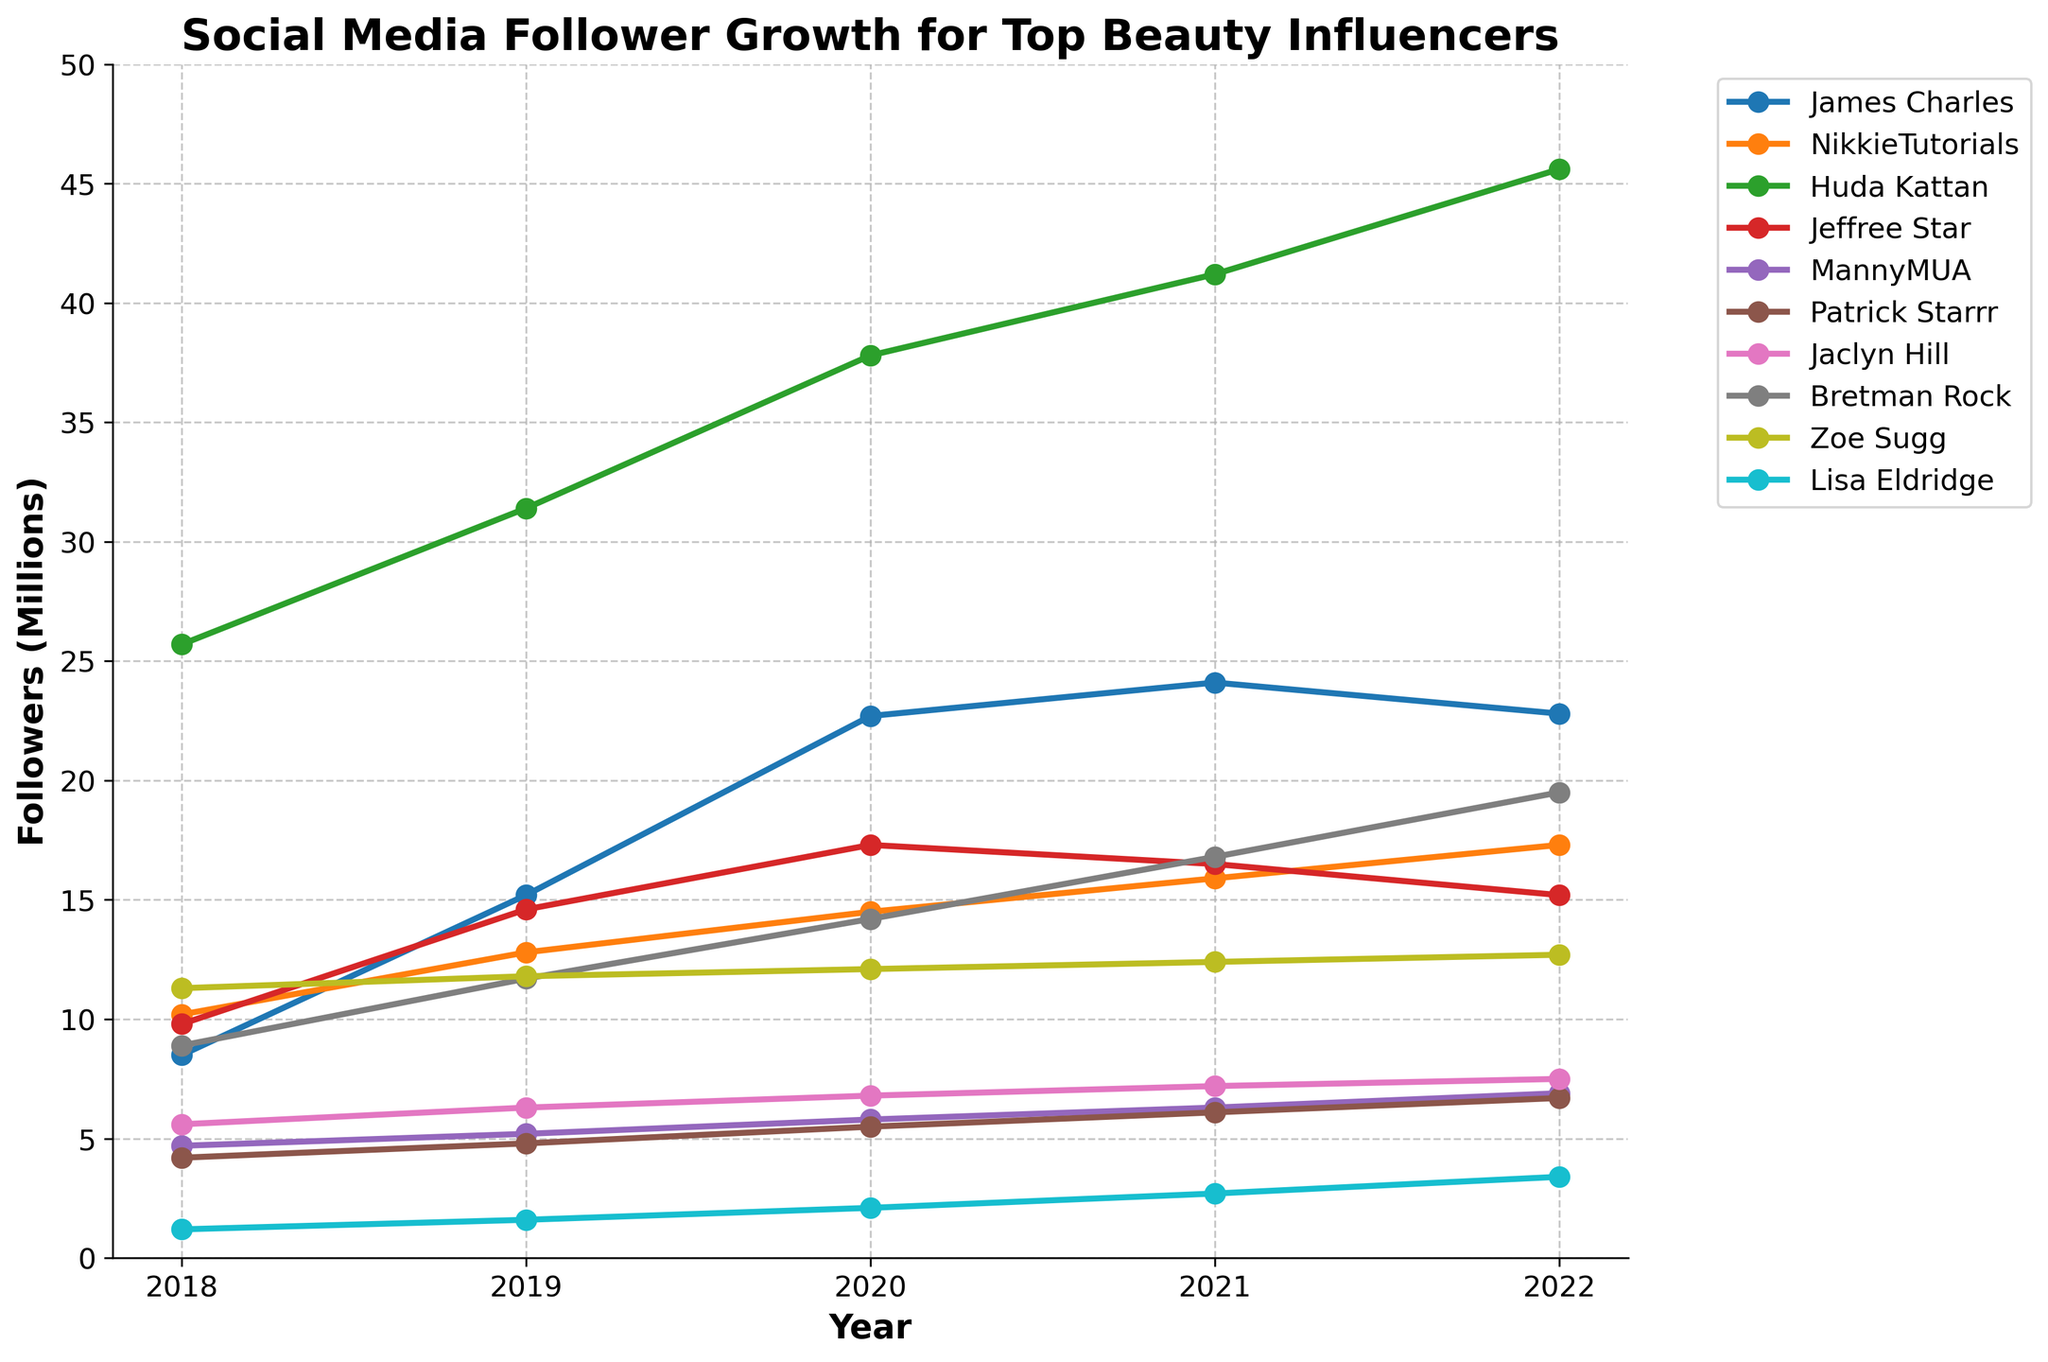What's the total follower growth for James Charles from 2018 to 2022? To find the total follower growth for James Charles, subtract his followers in 2018 from his followers in 2022: 22.8 - 8.5 = 14.3 million.
Answer: 14.3 million Which influencer had the highest number of followers in 2022? By examining the data for 2022, Huda Kattan had the highest number of followers at 45.6 million.
Answer: Huda Kattan Who experienced a decline in followers between 2021 and 2022? By comparing the 2021 and 2022 follower counts, James Charles (24.1 to 22.8) and Jeffree Star (16.5 to 15.2) experienced a decline.
Answer: James Charles, Jeffree Star What is the average follower count for MannyMUA from 2018 to 2022? To find the average, sum MannyMUA's followers for each year and divide by the number of years: (4.7 + 5.2 + 5.8 + 6.3 + 6.9) / 5 = 5.78 million.
Answer: 5.78 million Who had a faster growth rate between 2018 and 2022, NikkieTutorials or Bretman Rock? Calculate the growth for both NikkieTutorials (17.3 - 10.2 = 7.1 million) and Bretman Rock (19.5 - 8.9 = 10.6 million). Bretman Rock had a faster growth rate.
Answer: Bretman Rock Which influencer had the slowest growth in followers from 2018 to 2022? Determine the growth for each influencer and find the smallest increase. Zoe Sugg's growth was the smallest (12.7 - 11.3 = 1.4 million).
Answer: Zoe Sugg How many influencers had over 20 million followers in 2022? By examining the follower count for 2022, two influencers (James Charles and Huda Kattan) had over 20 million followers.
Answer: Two What was the increase in followers for Lisa Eldridge from 2020 to 2022? Subtract Lisa Eldridge's followers in 2020 from her followers in 2022: 3.4 - 2.1 = 1.3 million.
Answer: 1.3 million Which influencer had a peak follower count in 2020 and then saw a decline? By examining the data, James Charles peaked in 2020 (22.7 million) and then saw a decline.
Answer: James Charles Compare the follower growth (in millions) of Huda Kattan between 2018-2020 and 2020-2022. Who grew more? Calculate the growth in both periods: 2018-2020 (37.8 - 25.7 = 12.1 million), 2020-2022 (45.6 - 37.8 = 7.8 million). Huda Kattan grew more from 2018-2020.
Answer: 2018-2020 